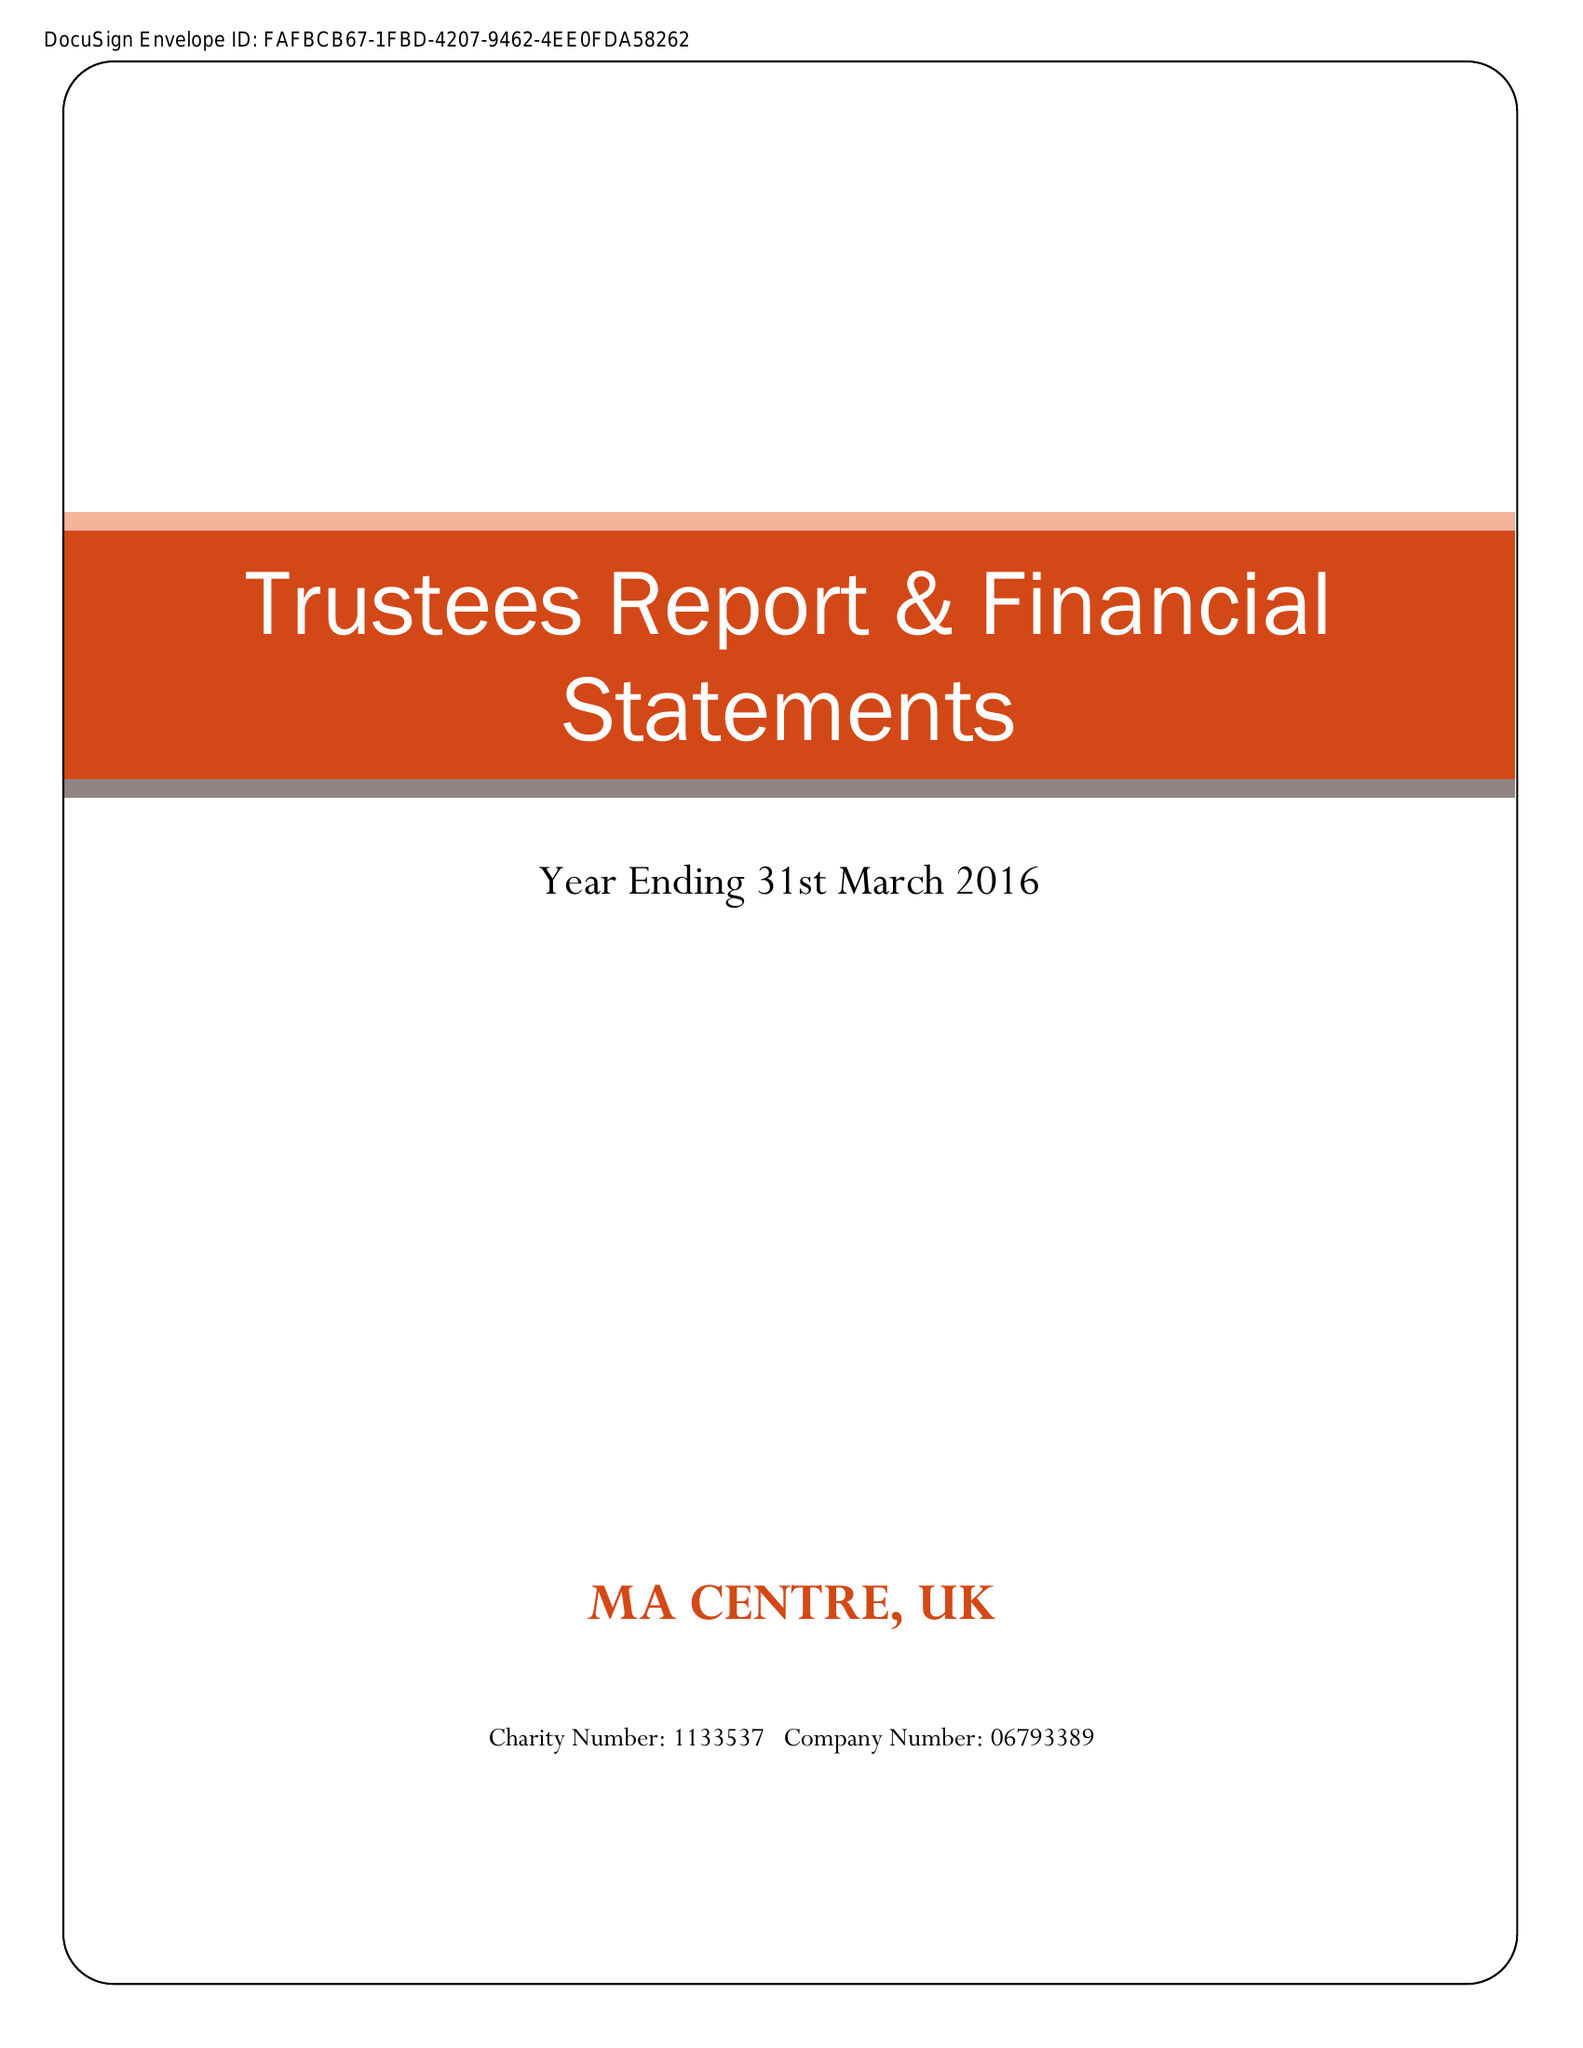What is the value for the income_annually_in_british_pounds?
Answer the question using a single word or phrase. 43790.00 